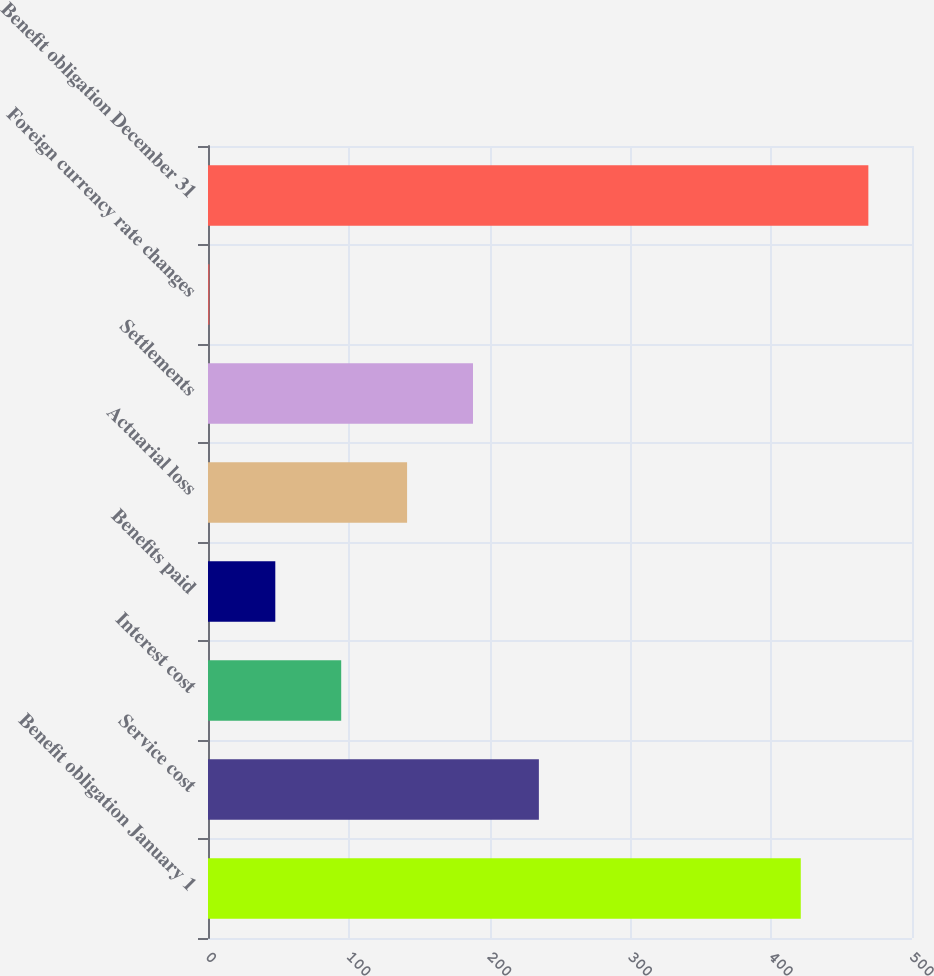Convert chart to OTSL. <chart><loc_0><loc_0><loc_500><loc_500><bar_chart><fcel>Benefit obligation January 1<fcel>Service cost<fcel>Interest cost<fcel>Benefits paid<fcel>Actuarial loss<fcel>Settlements<fcel>Foreign currency rate changes<fcel>Benefit obligation December 31<nl><fcel>421<fcel>235<fcel>94.6<fcel>47.8<fcel>141.4<fcel>188.2<fcel>1<fcel>469<nl></chart> 